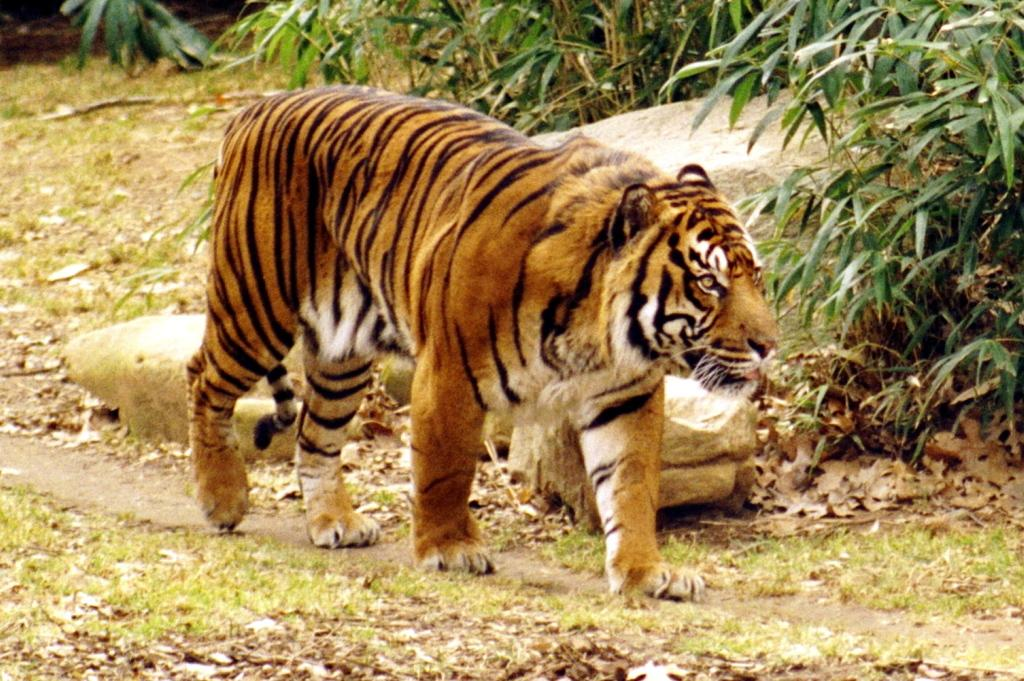What type of animal is in the image? There is a tiger in the image. What can be seen beneath the tiger? The ground is visible in the image. What type of vegetation is present in the image? There is grass in the image, as well as plants. What other objects can be seen on the ground? Stones and dried leaves are visible in the image. How many friends are standing near the jar and gate in the image? There is no jar or gate present in the image, and therefore no friends can be observed near them. 